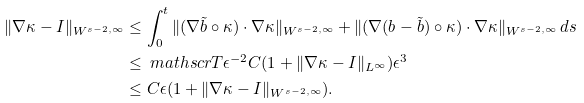Convert formula to latex. <formula><loc_0><loc_0><loc_500><loc_500>\| \nabla \kappa - I \| _ { W ^ { s - 2 , \infty } } & \leq \int _ { 0 } ^ { t } \| ( \nabla \tilde { b } \circ \kappa ) \cdot \nabla \kappa \| _ { W ^ { s - 2 , \infty } } + \| ( \nabla ( b - \tilde { b } ) \circ \kappa ) \cdot \nabla \kappa \| _ { W ^ { s - 2 , \infty } } \, d s \\ & \leq \ m a t h s c r { T } \epsilon ^ { - 2 } C ( 1 + \| \nabla \kappa - I \| _ { L ^ { \infty } } ) \epsilon ^ { 3 } \\ & \leq C \epsilon ( 1 + \| \nabla \kappa - I \| _ { W ^ { s - 2 , \infty } } ) .</formula> 